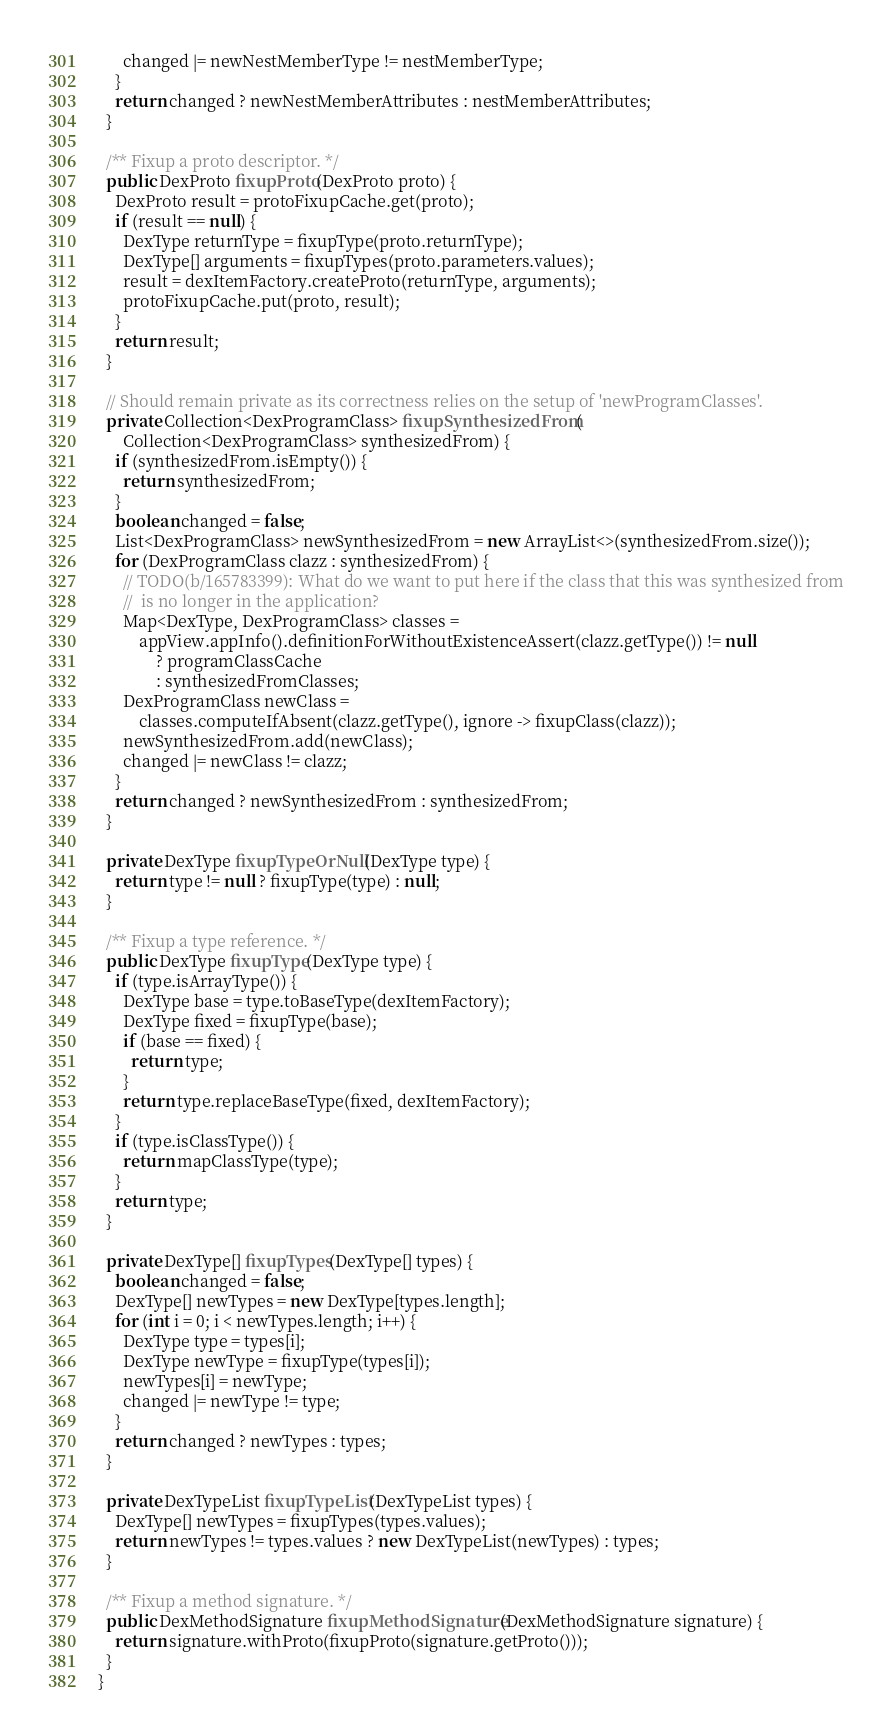<code> <loc_0><loc_0><loc_500><loc_500><_Java_>      changed |= newNestMemberType != nestMemberType;
    }
    return changed ? newNestMemberAttributes : nestMemberAttributes;
  }

  /** Fixup a proto descriptor. */
  public DexProto fixupProto(DexProto proto) {
    DexProto result = protoFixupCache.get(proto);
    if (result == null) {
      DexType returnType = fixupType(proto.returnType);
      DexType[] arguments = fixupTypes(proto.parameters.values);
      result = dexItemFactory.createProto(returnType, arguments);
      protoFixupCache.put(proto, result);
    }
    return result;
  }

  // Should remain private as its correctness relies on the setup of 'newProgramClasses'.
  private Collection<DexProgramClass> fixupSynthesizedFrom(
      Collection<DexProgramClass> synthesizedFrom) {
    if (synthesizedFrom.isEmpty()) {
      return synthesizedFrom;
    }
    boolean changed = false;
    List<DexProgramClass> newSynthesizedFrom = new ArrayList<>(synthesizedFrom.size());
    for (DexProgramClass clazz : synthesizedFrom) {
      // TODO(b/165783399): What do we want to put here if the class that this was synthesized from
      //  is no longer in the application?
      Map<DexType, DexProgramClass> classes =
          appView.appInfo().definitionForWithoutExistenceAssert(clazz.getType()) != null
              ? programClassCache
              : synthesizedFromClasses;
      DexProgramClass newClass =
          classes.computeIfAbsent(clazz.getType(), ignore -> fixupClass(clazz));
      newSynthesizedFrom.add(newClass);
      changed |= newClass != clazz;
    }
    return changed ? newSynthesizedFrom : synthesizedFrom;
  }

  private DexType fixupTypeOrNull(DexType type) {
    return type != null ? fixupType(type) : null;
  }

  /** Fixup a type reference. */
  public DexType fixupType(DexType type) {
    if (type.isArrayType()) {
      DexType base = type.toBaseType(dexItemFactory);
      DexType fixed = fixupType(base);
      if (base == fixed) {
        return type;
      }
      return type.replaceBaseType(fixed, dexItemFactory);
    }
    if (type.isClassType()) {
      return mapClassType(type);
    }
    return type;
  }

  private DexType[] fixupTypes(DexType[] types) {
    boolean changed = false;
    DexType[] newTypes = new DexType[types.length];
    for (int i = 0; i < newTypes.length; i++) {
      DexType type = types[i];
      DexType newType = fixupType(types[i]);
      newTypes[i] = newType;
      changed |= newType != type;
    }
    return changed ? newTypes : types;
  }

  private DexTypeList fixupTypeList(DexTypeList types) {
    DexType[] newTypes = fixupTypes(types.values);
    return newTypes != types.values ? new DexTypeList(newTypes) : types;
  }

  /** Fixup a method signature. */
  public DexMethodSignature fixupMethodSignature(DexMethodSignature signature) {
    return signature.withProto(fixupProto(signature.getProto()));
  }
}
</code> 